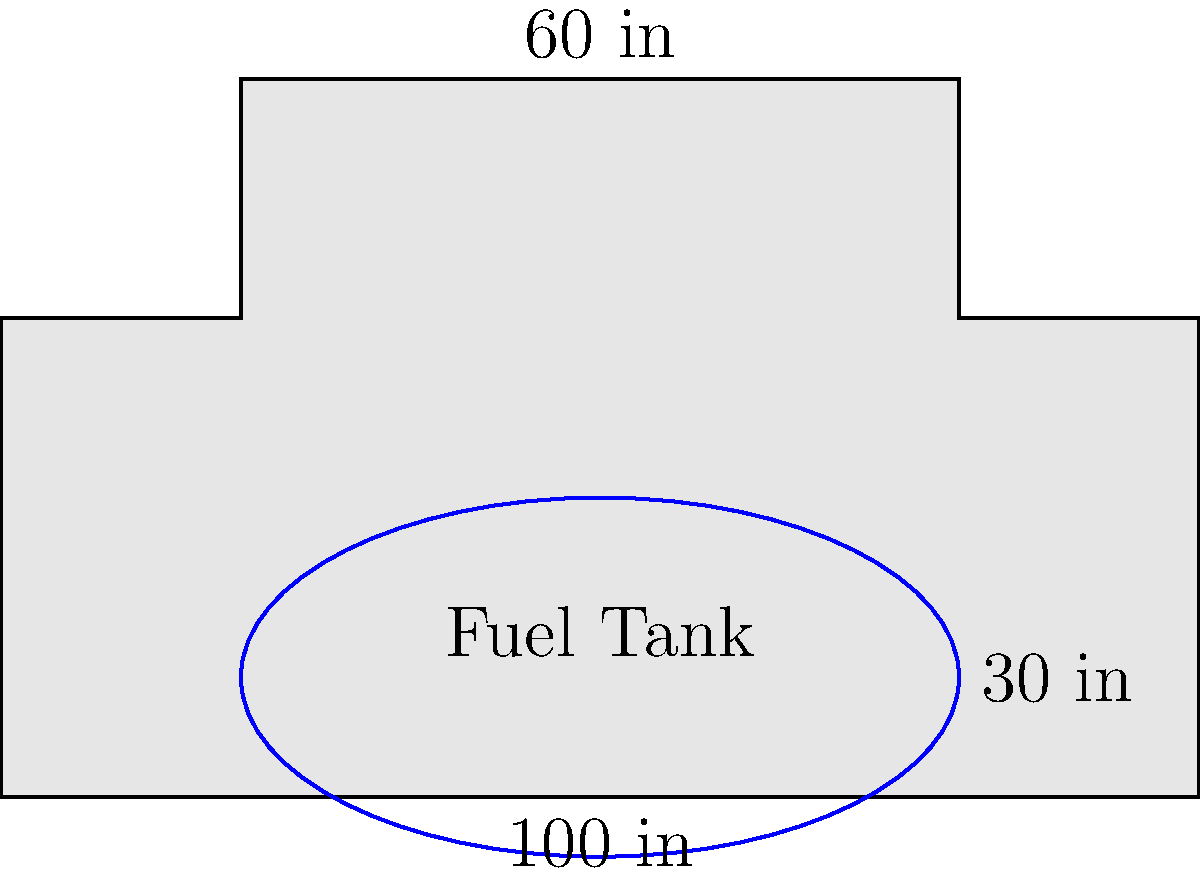As a truck driver, you're always conscious of your fuel efficiency. Your truck's fuel tank is shaped like an ellipse with a major axis of 60 inches and a minor axis of 30 inches. If you've driven 500 miles and used 3/4 of your tank, what is your fuel efficiency in miles per gallon? Assume the tank's depth is 20 inches and use $\pi \approx 3.14$. Let's approach this step-by-step:

1) First, we need to calculate the volume of the elliptical fuel tank:
   Volume of an ellipsoid = $\frac{4}{3}\pi abc$, where a, b, and c are the semi-axes.
   In this case, $a = 30$ in, $b = 15$ in, and $c = 10$ in (half of 20 in depth).

   $V = \frac{4}{3} \pi (30)(15)(10) = 18,840\pi$ cubic inches

2) Convert cubic inches to gallons:
   1 gallon = 231 cubic inches
   Tank capacity = $\frac{18,840\pi}{231} \approx 256.3$ gallons

3) You've used 3/4 of the tank, so:
   Fuel used = $0.75 \times 256.3 \approx 192.2$ gallons

4) Calculate fuel efficiency:
   Efficiency = Distance traveled / Fuel used
               = 500 miles / 192.2 gallons
               $\approx 2.60$ miles per gallon

Therefore, your fuel efficiency is approximately 2.60 miles per gallon.
Answer: 2.60 mpg 